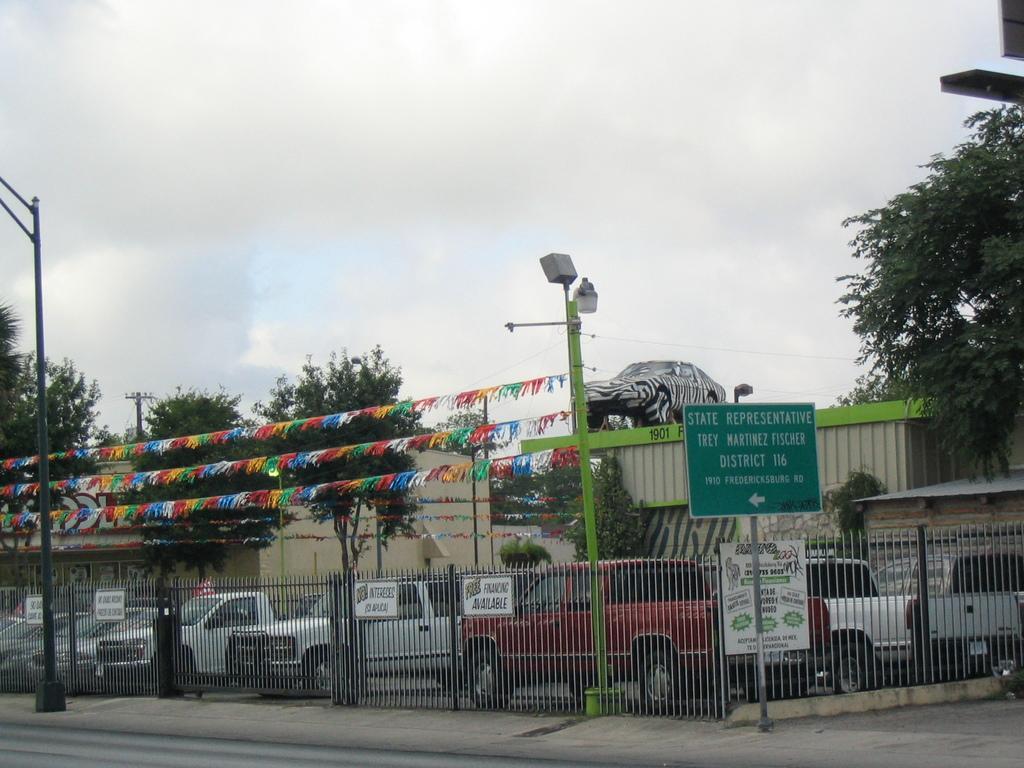Describe this image in one or two sentences. In the center of the image we can see the buildings, vehicles, fencing, boards, wall, trees, poles, electric light poles, wires. At the bottom of the image we can see the road. At the top of the image we can see the clouds are present in the sky. 